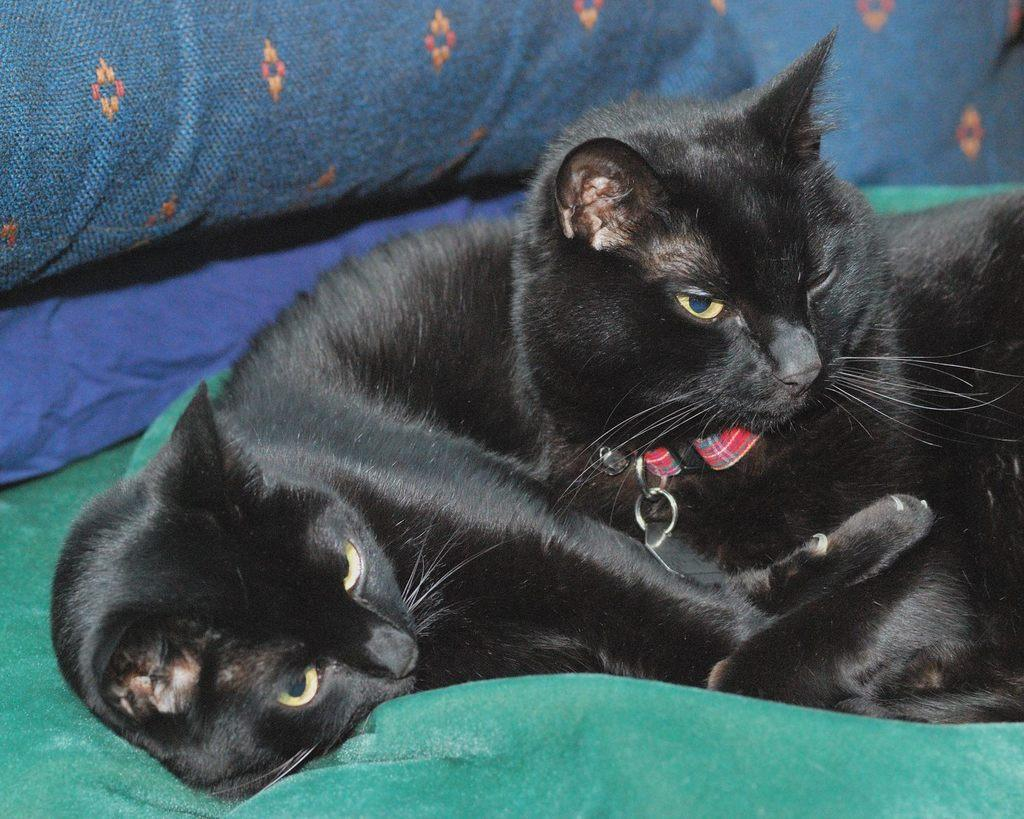How many cats can be seen in the image? There are two cats in the image. Where are the cats located in the image? The cats are in the middle of the image. What objects are present at the top of the image? There are pillows at the top of the image. What type of potato is being used as a decoration in the image? There is no potato present in the image. What kind of drug can be seen in the hands of the cats in the image? There are no drugs or cats holding anything in the image. 